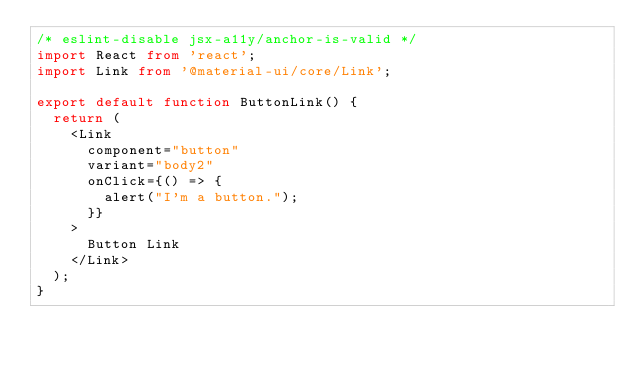<code> <loc_0><loc_0><loc_500><loc_500><_TypeScript_>/* eslint-disable jsx-a11y/anchor-is-valid */
import React from 'react';
import Link from '@material-ui/core/Link';

export default function ButtonLink() {
  return (
    <Link
      component="button"
      variant="body2"
      onClick={() => {
        alert("I'm a button.");
      }}
    >
      Button Link
    </Link>
  );
}
</code> 